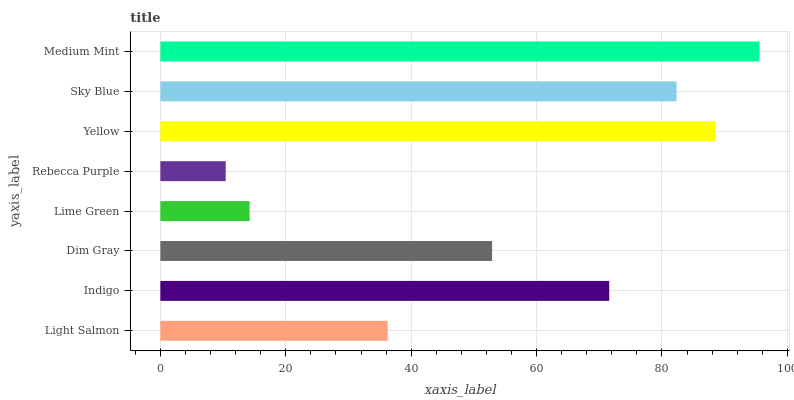Is Rebecca Purple the minimum?
Answer yes or no. Yes. Is Medium Mint the maximum?
Answer yes or no. Yes. Is Indigo the minimum?
Answer yes or no. No. Is Indigo the maximum?
Answer yes or no. No. Is Indigo greater than Light Salmon?
Answer yes or no. Yes. Is Light Salmon less than Indigo?
Answer yes or no. Yes. Is Light Salmon greater than Indigo?
Answer yes or no. No. Is Indigo less than Light Salmon?
Answer yes or no. No. Is Indigo the high median?
Answer yes or no. Yes. Is Dim Gray the low median?
Answer yes or no. Yes. Is Light Salmon the high median?
Answer yes or no. No. Is Lime Green the low median?
Answer yes or no. No. 